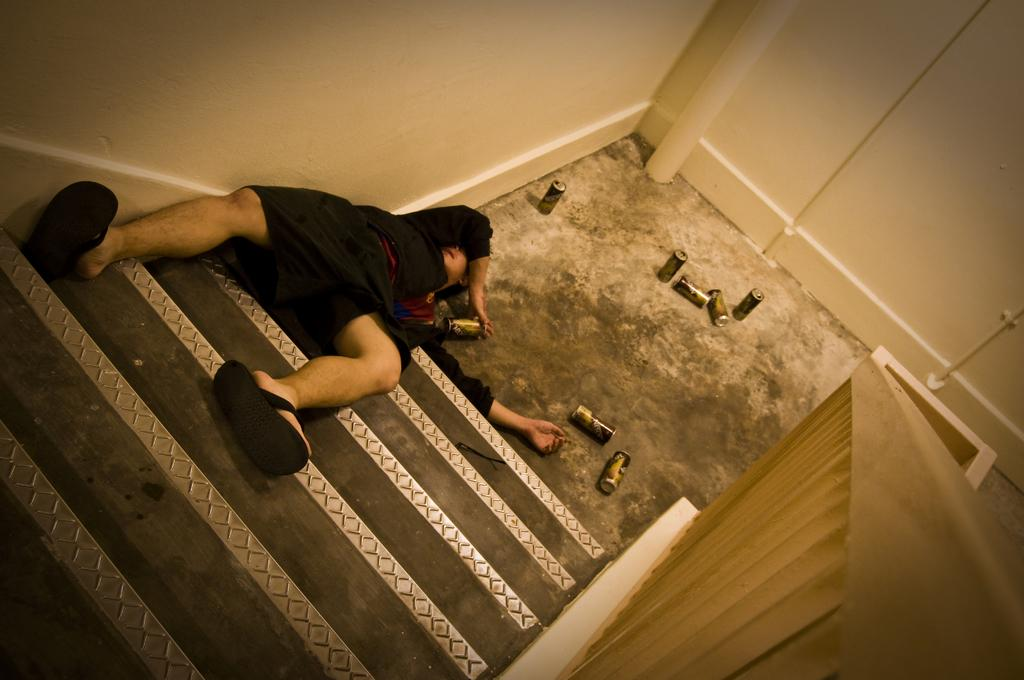What is the position of the man in the image? There is a man lying on the staircase. What can be seen on the ground in the image? There are twins on the ground. What is a feature of the environment in the image? There is a wall in the image. What type of railing is present in the image? There is a steel railing in the image. What type of card is the man holding in the image? There is no card present in the image; the man is lying on the staircase. What is the man's belief about the twins in the image? There is no information about the man's beliefs in the image; it only shows his position on the staircase and the presence of the twins on the ground. 